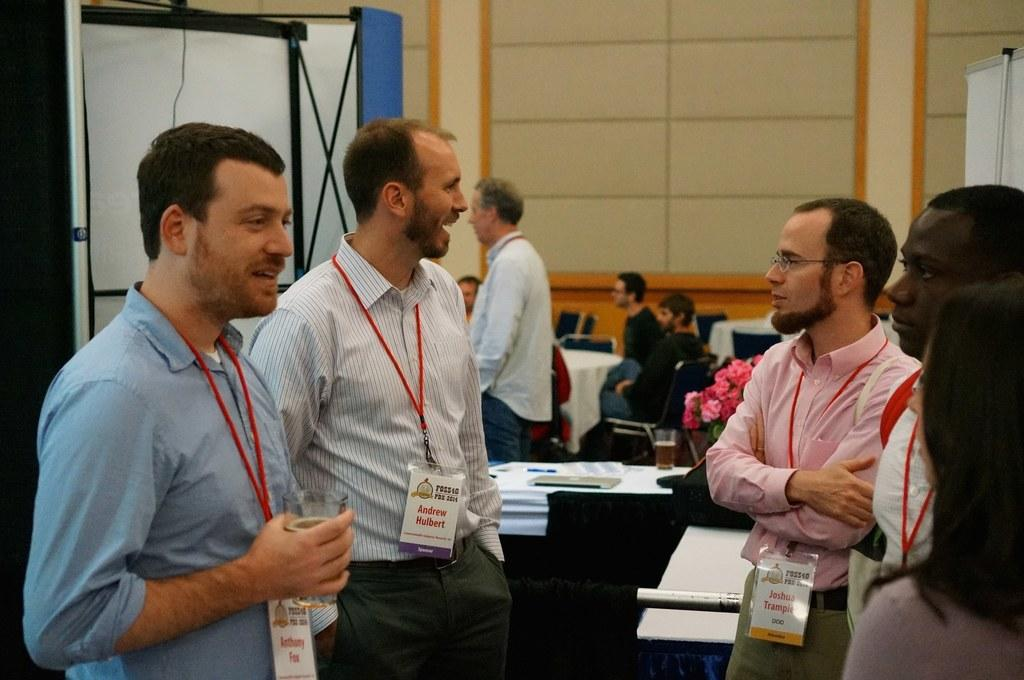How many people are in the image? There is a group of persons in the image, but the exact number is not specified. What can be seen in the image besides the persons? There are chairs, objects on a table, a wall, and stands visible in the image. What might the persons be sitting on? The chairs in the image suggest that the persons might be sitting. What is visible behind the persons? There is a wall and stands visible behind the persons. What type of care can be seen being provided to the box in the image? There is no box present in the image, so no care can be provided to it. 